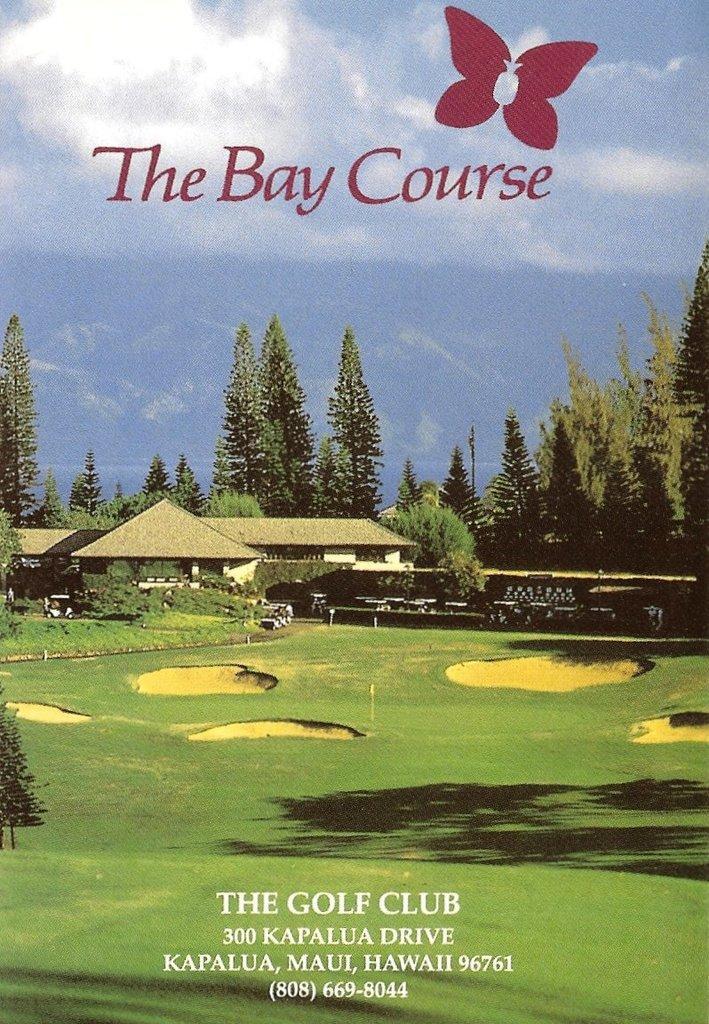<image>
Offer a succinct explanation of the picture presented. The Bay Course golf course is advertised with a Hawaii address shown. 